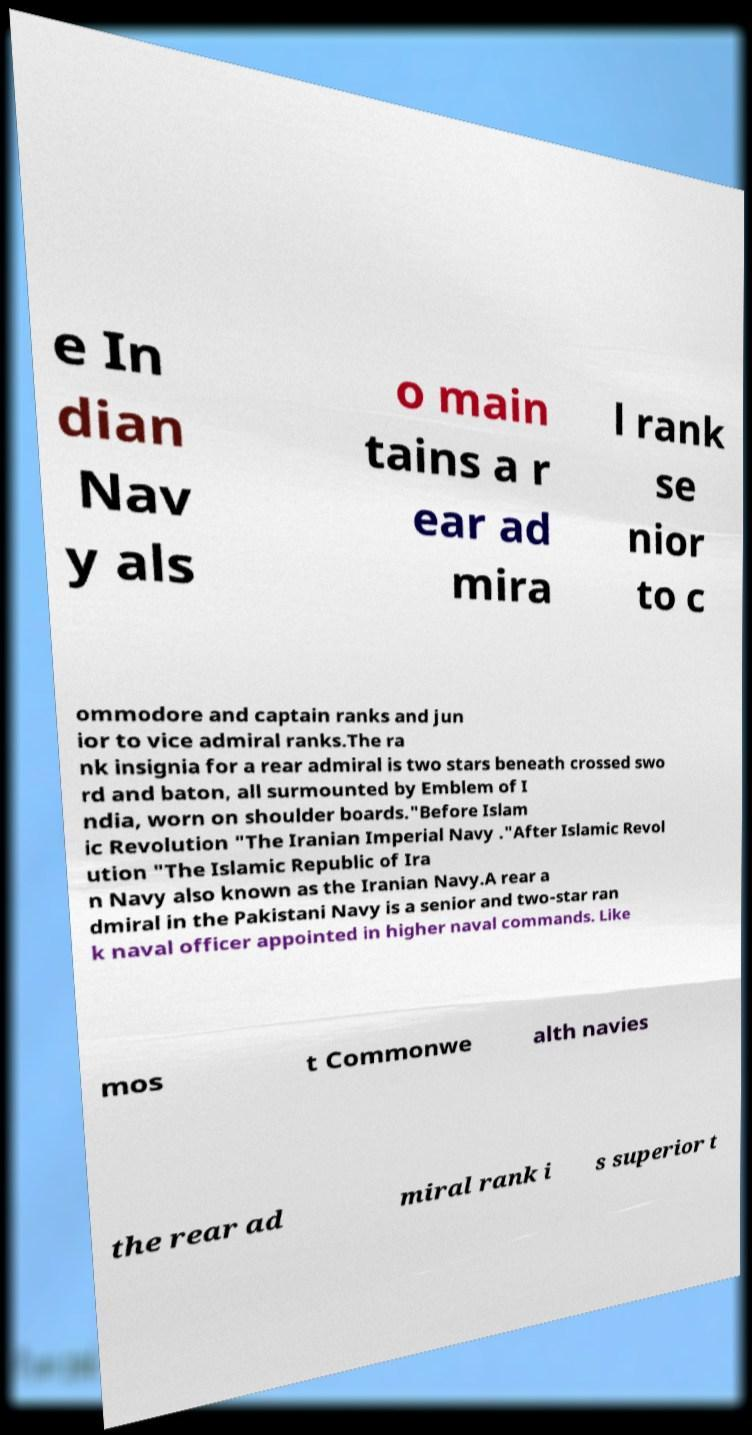Could you extract and type out the text from this image? e In dian Nav y als o main tains a r ear ad mira l rank se nior to c ommodore and captain ranks and jun ior to vice admiral ranks.The ra nk insignia for a rear admiral is two stars beneath crossed swo rd and baton, all surmounted by Emblem of I ndia, worn on shoulder boards."Before Islam ic Revolution "The Iranian Imperial Navy ."After Islamic Revol ution "The Islamic Republic of Ira n Navy also known as the Iranian Navy.A rear a dmiral in the Pakistani Navy is a senior and two-star ran k naval officer appointed in higher naval commands. Like mos t Commonwe alth navies the rear ad miral rank i s superior t 